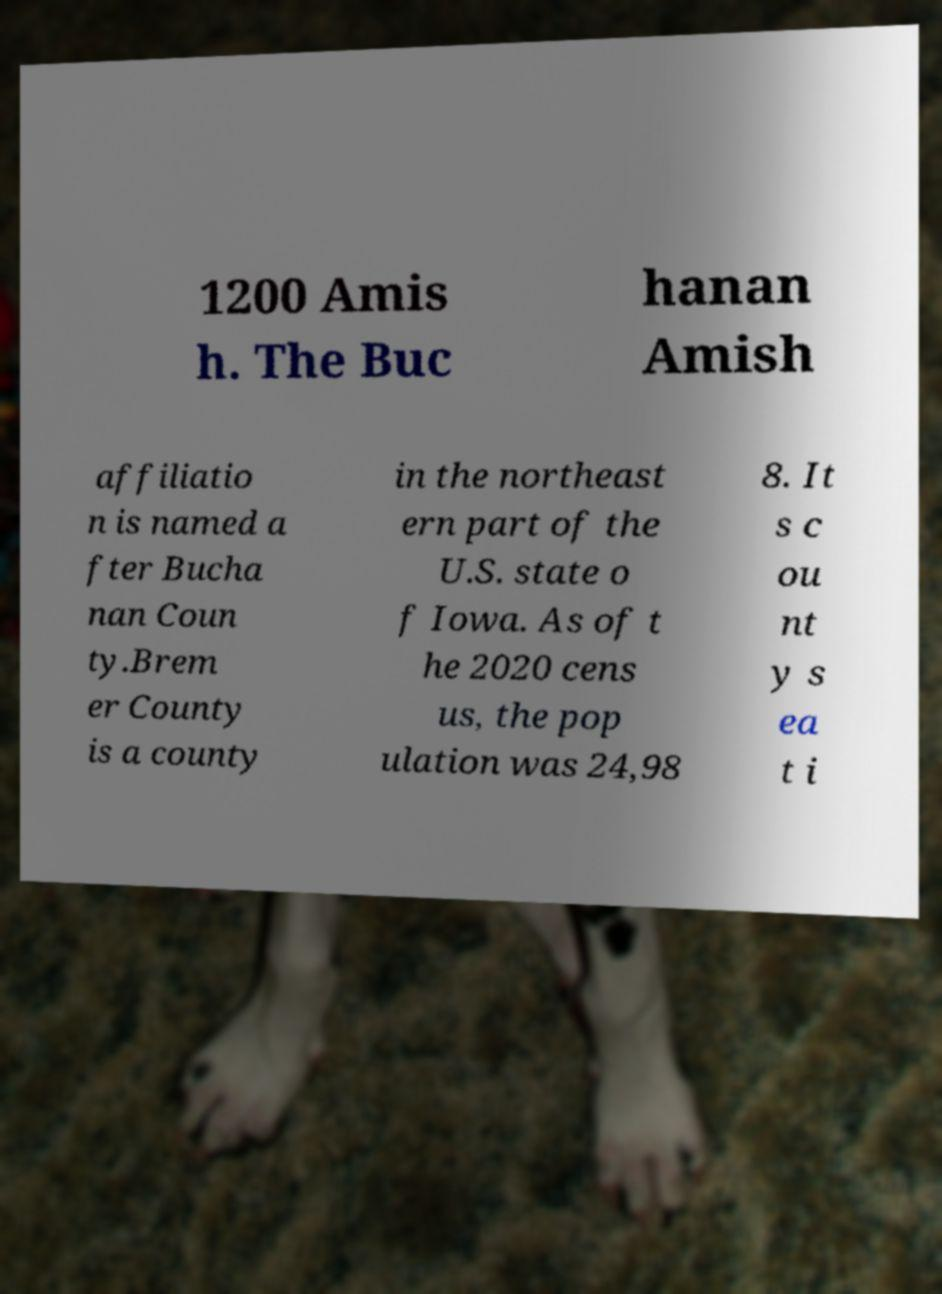For documentation purposes, I need the text within this image transcribed. Could you provide that? 1200 Amis h. The Buc hanan Amish affiliatio n is named a fter Bucha nan Coun ty.Brem er County is a county in the northeast ern part of the U.S. state o f Iowa. As of t he 2020 cens us, the pop ulation was 24,98 8. It s c ou nt y s ea t i 